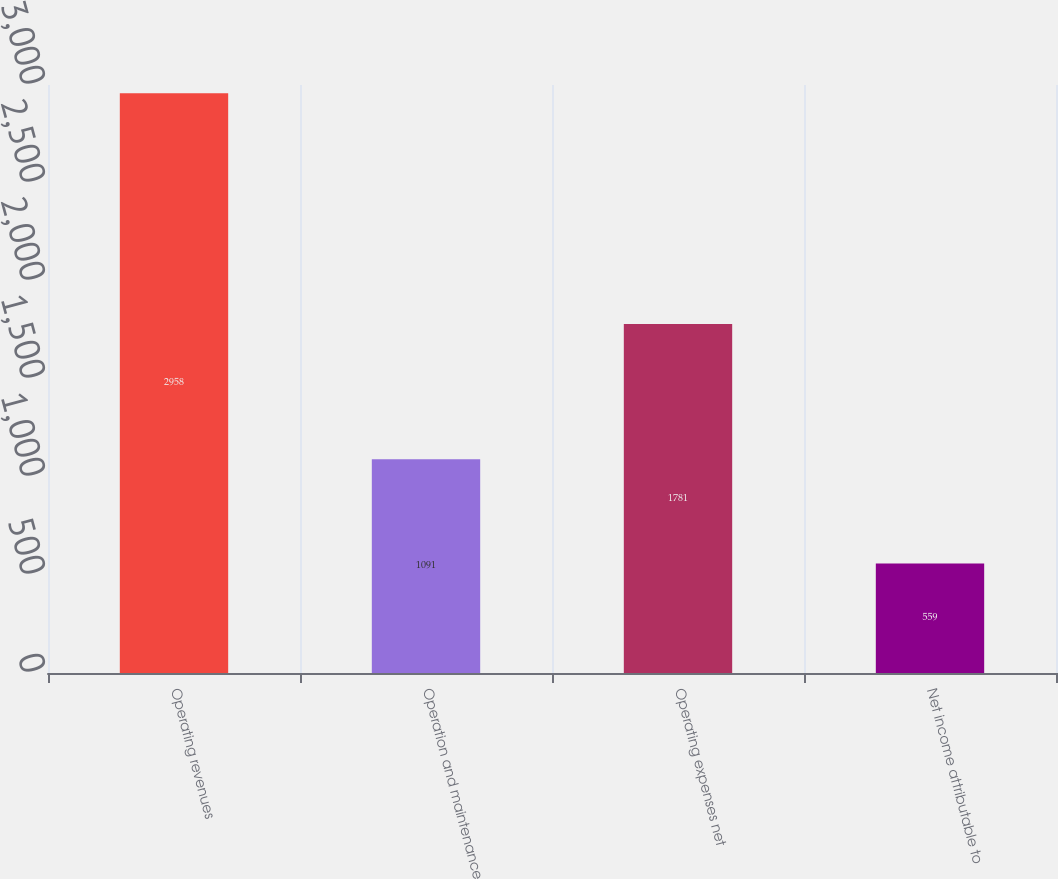<chart> <loc_0><loc_0><loc_500><loc_500><bar_chart><fcel>Operating revenues<fcel>Operation and maintenance<fcel>Operating expenses net<fcel>Net income attributable to<nl><fcel>2958<fcel>1091<fcel>1781<fcel>559<nl></chart> 